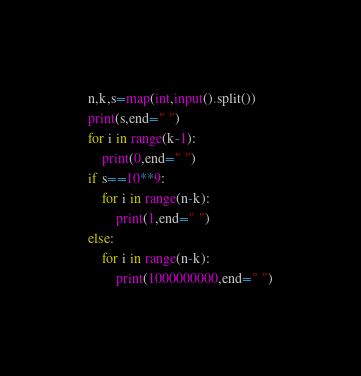<code> <loc_0><loc_0><loc_500><loc_500><_Python_>n,k,s=map(int,input().split())
print(s,end=" ")
for i in range(k-1):
    print(0,end=" ")
if s==10**9:
    for i in range(n-k):
        print(1,end=" ")
else:
    for i in range(n-k):
        print(1000000000,end=" ")</code> 